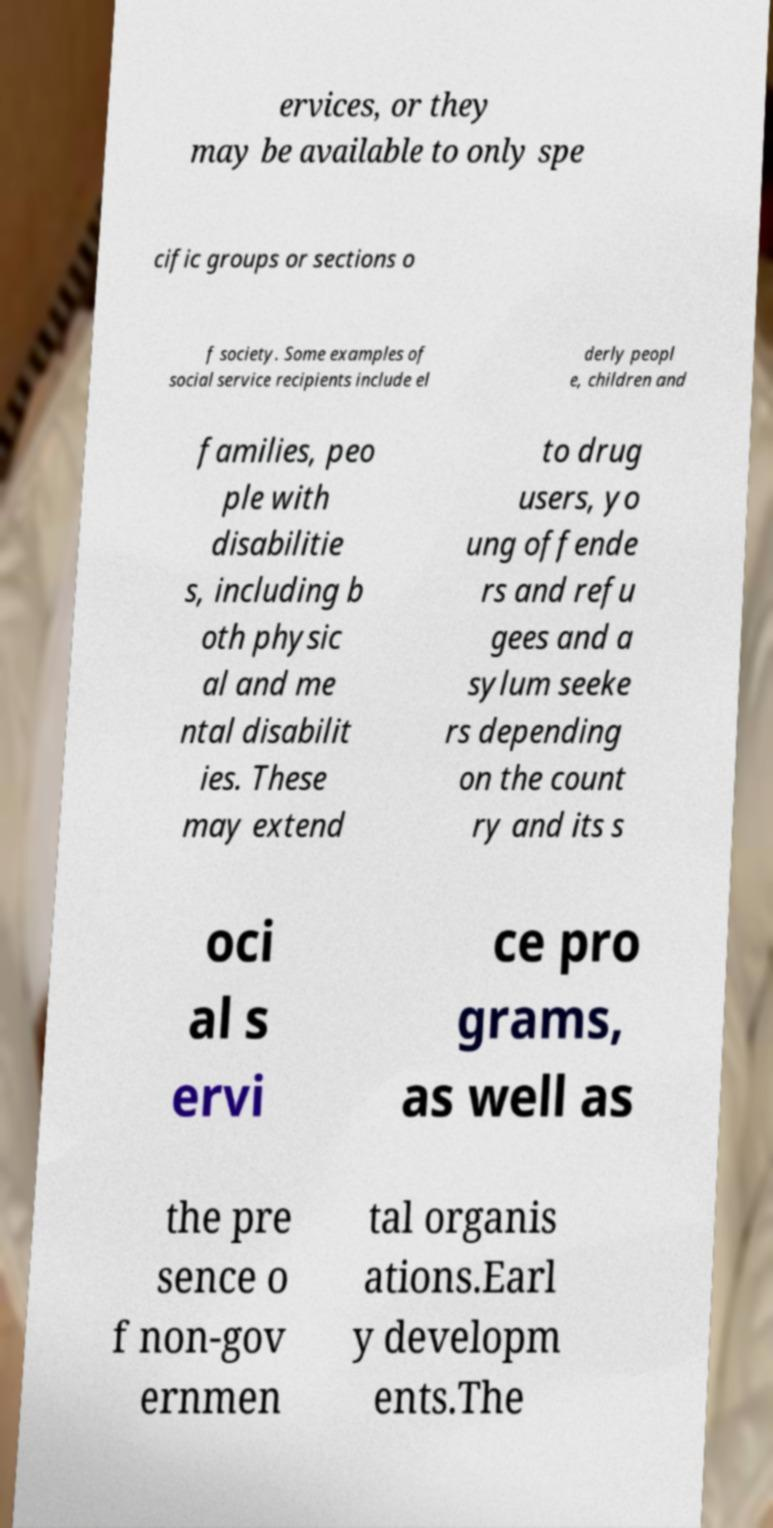Could you extract and type out the text from this image? ervices, or they may be available to only spe cific groups or sections o f society. Some examples of social service recipients include el derly peopl e, children and families, peo ple with disabilitie s, including b oth physic al and me ntal disabilit ies. These may extend to drug users, yo ung offende rs and refu gees and a sylum seeke rs depending on the count ry and its s oci al s ervi ce pro grams, as well as the pre sence o f non-gov ernmen tal organis ations.Earl y developm ents.The 